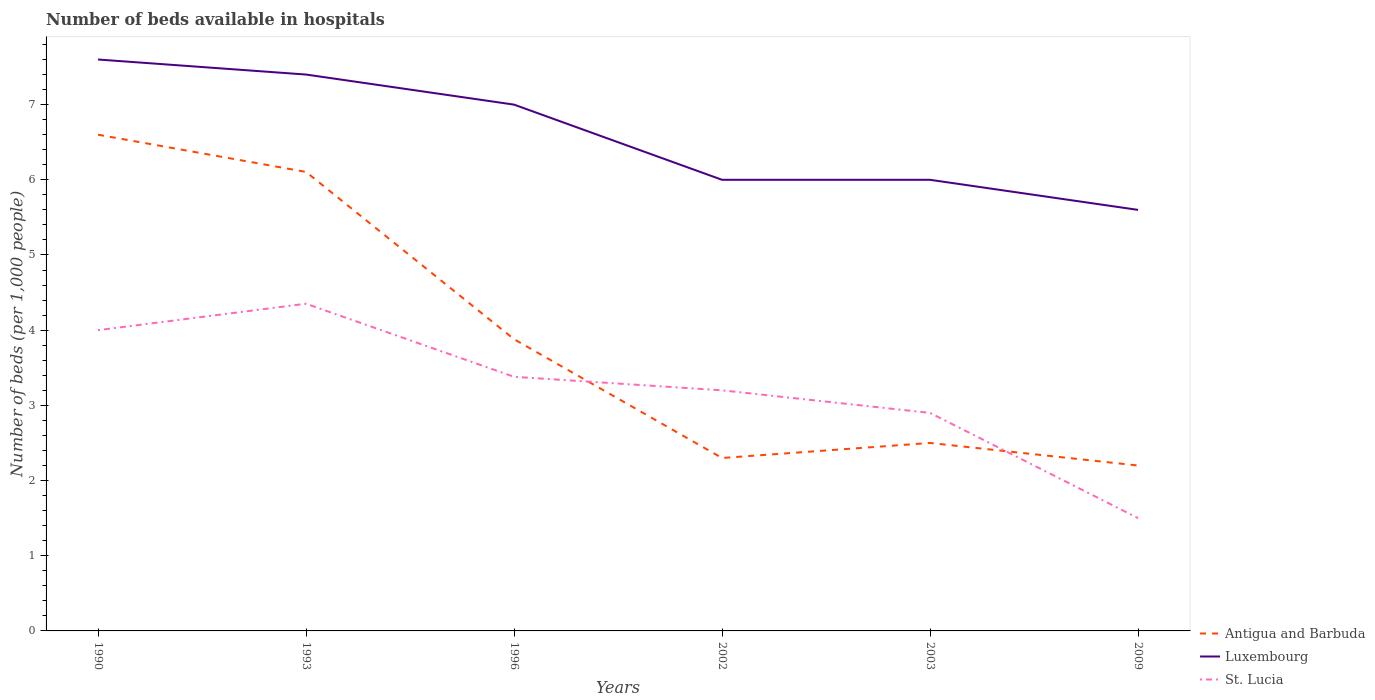What is the total number of beds in the hospiatls of in Antigua and Barbuda in the graph?
Ensure brevity in your answer.  4.1. What is the difference between the highest and the second highest number of beds in the hospiatls of in St. Lucia?
Give a very brief answer. 2.85. How many years are there in the graph?
Your answer should be very brief. 6. Does the graph contain any zero values?
Offer a very short reply. No. Does the graph contain grids?
Ensure brevity in your answer.  No. Where does the legend appear in the graph?
Give a very brief answer. Bottom right. How many legend labels are there?
Offer a very short reply. 3. How are the legend labels stacked?
Make the answer very short. Vertical. What is the title of the graph?
Offer a terse response. Number of beds available in hospitals. What is the label or title of the Y-axis?
Provide a short and direct response. Number of beds (per 1,0 people). What is the Number of beds (per 1,000 people) of Antigua and Barbuda in 1990?
Ensure brevity in your answer.  6.6. What is the Number of beds (per 1,000 people) in Luxembourg in 1990?
Offer a very short reply. 7.6. What is the Number of beds (per 1,000 people) of Antigua and Barbuda in 1993?
Provide a short and direct response. 6.1. What is the Number of beds (per 1,000 people) in Luxembourg in 1993?
Keep it short and to the point. 7.4. What is the Number of beds (per 1,000 people) in St. Lucia in 1993?
Provide a short and direct response. 4.35. What is the Number of beds (per 1,000 people) in Antigua and Barbuda in 1996?
Provide a succinct answer. 3.88. What is the Number of beds (per 1,000 people) in Luxembourg in 1996?
Offer a terse response. 7. What is the Number of beds (per 1,000 people) of St. Lucia in 1996?
Provide a succinct answer. 3.38. What is the Number of beds (per 1,000 people) in Luxembourg in 2002?
Ensure brevity in your answer.  6. What is the Number of beds (per 1,000 people) in St. Lucia in 2002?
Provide a succinct answer. 3.2. What is the Number of beds (per 1,000 people) in Antigua and Barbuda in 2003?
Offer a terse response. 2.5. What is the Number of beds (per 1,000 people) of Luxembourg in 2003?
Ensure brevity in your answer.  6. What is the Number of beds (per 1,000 people) in Antigua and Barbuda in 2009?
Ensure brevity in your answer.  2.2. What is the Number of beds (per 1,000 people) in St. Lucia in 2009?
Ensure brevity in your answer.  1.5. Across all years, what is the maximum Number of beds (per 1,000 people) in Antigua and Barbuda?
Your answer should be very brief. 6.6. Across all years, what is the maximum Number of beds (per 1,000 people) in Luxembourg?
Give a very brief answer. 7.6. Across all years, what is the maximum Number of beds (per 1,000 people) in St. Lucia?
Keep it short and to the point. 4.35. Across all years, what is the minimum Number of beds (per 1,000 people) in Antigua and Barbuda?
Provide a short and direct response. 2.2. What is the total Number of beds (per 1,000 people) of Antigua and Barbuda in the graph?
Give a very brief answer. 23.58. What is the total Number of beds (per 1,000 people) of Luxembourg in the graph?
Your answer should be very brief. 39.6. What is the total Number of beds (per 1,000 people) of St. Lucia in the graph?
Your answer should be very brief. 19.33. What is the difference between the Number of beds (per 1,000 people) of Antigua and Barbuda in 1990 and that in 1993?
Make the answer very short. 0.5. What is the difference between the Number of beds (per 1,000 people) in St. Lucia in 1990 and that in 1993?
Offer a terse response. -0.35. What is the difference between the Number of beds (per 1,000 people) of Antigua and Barbuda in 1990 and that in 1996?
Keep it short and to the point. 2.72. What is the difference between the Number of beds (per 1,000 people) of St. Lucia in 1990 and that in 1996?
Keep it short and to the point. 0.62. What is the difference between the Number of beds (per 1,000 people) of Antigua and Barbuda in 1990 and that in 2002?
Your answer should be very brief. 4.3. What is the difference between the Number of beds (per 1,000 people) of Luxembourg in 1990 and that in 2002?
Offer a terse response. 1.6. What is the difference between the Number of beds (per 1,000 people) in St. Lucia in 1990 and that in 2002?
Provide a short and direct response. 0.8. What is the difference between the Number of beds (per 1,000 people) of St. Lucia in 1990 and that in 2003?
Your answer should be compact. 1.1. What is the difference between the Number of beds (per 1,000 people) in Antigua and Barbuda in 1990 and that in 2009?
Your answer should be compact. 4.4. What is the difference between the Number of beds (per 1,000 people) in Antigua and Barbuda in 1993 and that in 1996?
Offer a terse response. 2.22. What is the difference between the Number of beds (per 1,000 people) of St. Lucia in 1993 and that in 1996?
Keep it short and to the point. 0.97. What is the difference between the Number of beds (per 1,000 people) in Antigua and Barbuda in 1993 and that in 2002?
Provide a short and direct response. 3.8. What is the difference between the Number of beds (per 1,000 people) in Luxembourg in 1993 and that in 2002?
Your answer should be compact. 1.4. What is the difference between the Number of beds (per 1,000 people) in St. Lucia in 1993 and that in 2002?
Offer a terse response. 1.15. What is the difference between the Number of beds (per 1,000 people) in Antigua and Barbuda in 1993 and that in 2003?
Offer a very short reply. 3.6. What is the difference between the Number of beds (per 1,000 people) in St. Lucia in 1993 and that in 2003?
Provide a succinct answer. 1.45. What is the difference between the Number of beds (per 1,000 people) in Antigua and Barbuda in 1993 and that in 2009?
Provide a short and direct response. 3.9. What is the difference between the Number of beds (per 1,000 people) of Luxembourg in 1993 and that in 2009?
Your answer should be compact. 1.8. What is the difference between the Number of beds (per 1,000 people) in St. Lucia in 1993 and that in 2009?
Provide a short and direct response. 2.85. What is the difference between the Number of beds (per 1,000 people) of Antigua and Barbuda in 1996 and that in 2002?
Offer a terse response. 1.58. What is the difference between the Number of beds (per 1,000 people) in St. Lucia in 1996 and that in 2002?
Keep it short and to the point. 0.18. What is the difference between the Number of beds (per 1,000 people) in Antigua and Barbuda in 1996 and that in 2003?
Keep it short and to the point. 1.38. What is the difference between the Number of beds (per 1,000 people) in St. Lucia in 1996 and that in 2003?
Make the answer very short. 0.48. What is the difference between the Number of beds (per 1,000 people) in Antigua and Barbuda in 1996 and that in 2009?
Your answer should be very brief. 1.68. What is the difference between the Number of beds (per 1,000 people) in Luxembourg in 1996 and that in 2009?
Provide a succinct answer. 1.4. What is the difference between the Number of beds (per 1,000 people) in St. Lucia in 1996 and that in 2009?
Ensure brevity in your answer.  1.88. What is the difference between the Number of beds (per 1,000 people) in Antigua and Barbuda in 2002 and that in 2003?
Your answer should be very brief. -0.2. What is the difference between the Number of beds (per 1,000 people) of St. Lucia in 2002 and that in 2003?
Keep it short and to the point. 0.3. What is the difference between the Number of beds (per 1,000 people) of Antigua and Barbuda in 2002 and that in 2009?
Provide a short and direct response. 0.1. What is the difference between the Number of beds (per 1,000 people) in Luxembourg in 2002 and that in 2009?
Make the answer very short. 0.4. What is the difference between the Number of beds (per 1,000 people) of St. Lucia in 2002 and that in 2009?
Make the answer very short. 1.7. What is the difference between the Number of beds (per 1,000 people) of Antigua and Barbuda in 2003 and that in 2009?
Your answer should be compact. 0.3. What is the difference between the Number of beds (per 1,000 people) of Antigua and Barbuda in 1990 and the Number of beds (per 1,000 people) of St. Lucia in 1993?
Your answer should be very brief. 2.25. What is the difference between the Number of beds (per 1,000 people) of Luxembourg in 1990 and the Number of beds (per 1,000 people) of St. Lucia in 1993?
Provide a succinct answer. 3.25. What is the difference between the Number of beds (per 1,000 people) of Antigua and Barbuda in 1990 and the Number of beds (per 1,000 people) of Luxembourg in 1996?
Make the answer very short. -0.4. What is the difference between the Number of beds (per 1,000 people) in Antigua and Barbuda in 1990 and the Number of beds (per 1,000 people) in St. Lucia in 1996?
Your response must be concise. 3.22. What is the difference between the Number of beds (per 1,000 people) of Luxembourg in 1990 and the Number of beds (per 1,000 people) of St. Lucia in 1996?
Ensure brevity in your answer.  4.22. What is the difference between the Number of beds (per 1,000 people) in Antigua and Barbuda in 1990 and the Number of beds (per 1,000 people) in St. Lucia in 2002?
Keep it short and to the point. 3.4. What is the difference between the Number of beds (per 1,000 people) in Luxembourg in 1990 and the Number of beds (per 1,000 people) in St. Lucia in 2002?
Provide a short and direct response. 4.4. What is the difference between the Number of beds (per 1,000 people) of Antigua and Barbuda in 1990 and the Number of beds (per 1,000 people) of Luxembourg in 2003?
Your response must be concise. 0.6. What is the difference between the Number of beds (per 1,000 people) of Antigua and Barbuda in 1990 and the Number of beds (per 1,000 people) of St. Lucia in 2003?
Your answer should be very brief. 3.7. What is the difference between the Number of beds (per 1,000 people) of Luxembourg in 1990 and the Number of beds (per 1,000 people) of St. Lucia in 2009?
Your answer should be very brief. 6.1. What is the difference between the Number of beds (per 1,000 people) in Antigua and Barbuda in 1993 and the Number of beds (per 1,000 people) in Luxembourg in 1996?
Offer a terse response. -0.9. What is the difference between the Number of beds (per 1,000 people) in Antigua and Barbuda in 1993 and the Number of beds (per 1,000 people) in St. Lucia in 1996?
Your answer should be compact. 2.72. What is the difference between the Number of beds (per 1,000 people) in Luxembourg in 1993 and the Number of beds (per 1,000 people) in St. Lucia in 1996?
Your response must be concise. 4.02. What is the difference between the Number of beds (per 1,000 people) of Antigua and Barbuda in 1993 and the Number of beds (per 1,000 people) of Luxembourg in 2002?
Offer a terse response. 0.1. What is the difference between the Number of beds (per 1,000 people) in Antigua and Barbuda in 1993 and the Number of beds (per 1,000 people) in St. Lucia in 2002?
Provide a succinct answer. 2.9. What is the difference between the Number of beds (per 1,000 people) of Luxembourg in 1993 and the Number of beds (per 1,000 people) of St. Lucia in 2002?
Offer a very short reply. 4.2. What is the difference between the Number of beds (per 1,000 people) of Antigua and Barbuda in 1993 and the Number of beds (per 1,000 people) of Luxembourg in 2003?
Your answer should be very brief. 0.1. What is the difference between the Number of beds (per 1,000 people) in Antigua and Barbuda in 1993 and the Number of beds (per 1,000 people) in St. Lucia in 2003?
Make the answer very short. 3.2. What is the difference between the Number of beds (per 1,000 people) of Luxembourg in 1993 and the Number of beds (per 1,000 people) of St. Lucia in 2003?
Provide a succinct answer. 4.5. What is the difference between the Number of beds (per 1,000 people) of Antigua and Barbuda in 1993 and the Number of beds (per 1,000 people) of Luxembourg in 2009?
Keep it short and to the point. 0.5. What is the difference between the Number of beds (per 1,000 people) in Antigua and Barbuda in 1993 and the Number of beds (per 1,000 people) in St. Lucia in 2009?
Make the answer very short. 4.6. What is the difference between the Number of beds (per 1,000 people) of Antigua and Barbuda in 1996 and the Number of beds (per 1,000 people) of Luxembourg in 2002?
Keep it short and to the point. -2.12. What is the difference between the Number of beds (per 1,000 people) in Antigua and Barbuda in 1996 and the Number of beds (per 1,000 people) in St. Lucia in 2002?
Ensure brevity in your answer.  0.68. What is the difference between the Number of beds (per 1,000 people) in Luxembourg in 1996 and the Number of beds (per 1,000 people) in St. Lucia in 2002?
Give a very brief answer. 3.8. What is the difference between the Number of beds (per 1,000 people) in Antigua and Barbuda in 1996 and the Number of beds (per 1,000 people) in Luxembourg in 2003?
Your answer should be very brief. -2.12. What is the difference between the Number of beds (per 1,000 people) in Antigua and Barbuda in 1996 and the Number of beds (per 1,000 people) in Luxembourg in 2009?
Offer a very short reply. -1.72. What is the difference between the Number of beds (per 1,000 people) in Antigua and Barbuda in 1996 and the Number of beds (per 1,000 people) in St. Lucia in 2009?
Provide a short and direct response. 2.38. What is the difference between the Number of beds (per 1,000 people) in Antigua and Barbuda in 2002 and the Number of beds (per 1,000 people) in St. Lucia in 2003?
Offer a very short reply. -0.6. What is the difference between the Number of beds (per 1,000 people) in Antigua and Barbuda in 2002 and the Number of beds (per 1,000 people) in Luxembourg in 2009?
Ensure brevity in your answer.  -3.3. What is the difference between the Number of beds (per 1,000 people) of Antigua and Barbuda in 2003 and the Number of beds (per 1,000 people) of Luxembourg in 2009?
Your answer should be very brief. -3.1. What is the difference between the Number of beds (per 1,000 people) in Luxembourg in 2003 and the Number of beds (per 1,000 people) in St. Lucia in 2009?
Give a very brief answer. 4.5. What is the average Number of beds (per 1,000 people) of Antigua and Barbuda per year?
Your response must be concise. 3.93. What is the average Number of beds (per 1,000 people) of St. Lucia per year?
Offer a terse response. 3.22. In the year 1990, what is the difference between the Number of beds (per 1,000 people) in Antigua and Barbuda and Number of beds (per 1,000 people) in St. Lucia?
Keep it short and to the point. 2.6. In the year 1993, what is the difference between the Number of beds (per 1,000 people) of Antigua and Barbuda and Number of beds (per 1,000 people) of Luxembourg?
Your answer should be very brief. -1.3. In the year 1993, what is the difference between the Number of beds (per 1,000 people) of Antigua and Barbuda and Number of beds (per 1,000 people) of St. Lucia?
Your answer should be compact. 1.75. In the year 1993, what is the difference between the Number of beds (per 1,000 people) of Luxembourg and Number of beds (per 1,000 people) of St. Lucia?
Provide a succinct answer. 3.05. In the year 1996, what is the difference between the Number of beds (per 1,000 people) of Antigua and Barbuda and Number of beds (per 1,000 people) of Luxembourg?
Your answer should be very brief. -3.12. In the year 1996, what is the difference between the Number of beds (per 1,000 people) in Luxembourg and Number of beds (per 1,000 people) in St. Lucia?
Your answer should be very brief. 3.62. In the year 2002, what is the difference between the Number of beds (per 1,000 people) in Antigua and Barbuda and Number of beds (per 1,000 people) in Luxembourg?
Your response must be concise. -3.7. In the year 2003, what is the difference between the Number of beds (per 1,000 people) of Antigua and Barbuda and Number of beds (per 1,000 people) of Luxembourg?
Provide a succinct answer. -3.5. In the year 2009, what is the difference between the Number of beds (per 1,000 people) of Luxembourg and Number of beds (per 1,000 people) of St. Lucia?
Your answer should be very brief. 4.1. What is the ratio of the Number of beds (per 1,000 people) in Antigua and Barbuda in 1990 to that in 1993?
Your response must be concise. 1.08. What is the ratio of the Number of beds (per 1,000 people) of St. Lucia in 1990 to that in 1993?
Keep it short and to the point. 0.92. What is the ratio of the Number of beds (per 1,000 people) of Antigua and Barbuda in 1990 to that in 1996?
Provide a short and direct response. 1.7. What is the ratio of the Number of beds (per 1,000 people) in Luxembourg in 1990 to that in 1996?
Your answer should be very brief. 1.09. What is the ratio of the Number of beds (per 1,000 people) in St. Lucia in 1990 to that in 1996?
Keep it short and to the point. 1.18. What is the ratio of the Number of beds (per 1,000 people) of Antigua and Barbuda in 1990 to that in 2002?
Your answer should be very brief. 2.87. What is the ratio of the Number of beds (per 1,000 people) in Luxembourg in 1990 to that in 2002?
Give a very brief answer. 1.27. What is the ratio of the Number of beds (per 1,000 people) in St. Lucia in 1990 to that in 2002?
Make the answer very short. 1.25. What is the ratio of the Number of beds (per 1,000 people) of Antigua and Barbuda in 1990 to that in 2003?
Provide a short and direct response. 2.64. What is the ratio of the Number of beds (per 1,000 people) in Luxembourg in 1990 to that in 2003?
Offer a very short reply. 1.27. What is the ratio of the Number of beds (per 1,000 people) in St. Lucia in 1990 to that in 2003?
Offer a terse response. 1.38. What is the ratio of the Number of beds (per 1,000 people) in Luxembourg in 1990 to that in 2009?
Offer a terse response. 1.36. What is the ratio of the Number of beds (per 1,000 people) in St. Lucia in 1990 to that in 2009?
Provide a succinct answer. 2.67. What is the ratio of the Number of beds (per 1,000 people) in Antigua and Barbuda in 1993 to that in 1996?
Your answer should be very brief. 1.57. What is the ratio of the Number of beds (per 1,000 people) of Luxembourg in 1993 to that in 1996?
Give a very brief answer. 1.06. What is the ratio of the Number of beds (per 1,000 people) in St. Lucia in 1993 to that in 1996?
Give a very brief answer. 1.29. What is the ratio of the Number of beds (per 1,000 people) in Antigua and Barbuda in 1993 to that in 2002?
Provide a succinct answer. 2.65. What is the ratio of the Number of beds (per 1,000 people) of Luxembourg in 1993 to that in 2002?
Your answer should be very brief. 1.23. What is the ratio of the Number of beds (per 1,000 people) of St. Lucia in 1993 to that in 2002?
Offer a very short reply. 1.36. What is the ratio of the Number of beds (per 1,000 people) in Antigua and Barbuda in 1993 to that in 2003?
Make the answer very short. 2.44. What is the ratio of the Number of beds (per 1,000 people) of Luxembourg in 1993 to that in 2003?
Offer a terse response. 1.23. What is the ratio of the Number of beds (per 1,000 people) in St. Lucia in 1993 to that in 2003?
Ensure brevity in your answer.  1.5. What is the ratio of the Number of beds (per 1,000 people) of Antigua and Barbuda in 1993 to that in 2009?
Provide a short and direct response. 2.77. What is the ratio of the Number of beds (per 1,000 people) of Luxembourg in 1993 to that in 2009?
Your response must be concise. 1.32. What is the ratio of the Number of beds (per 1,000 people) of St. Lucia in 1993 to that in 2009?
Provide a succinct answer. 2.9. What is the ratio of the Number of beds (per 1,000 people) in Antigua and Barbuda in 1996 to that in 2002?
Your answer should be compact. 1.69. What is the ratio of the Number of beds (per 1,000 people) of Luxembourg in 1996 to that in 2002?
Your answer should be very brief. 1.17. What is the ratio of the Number of beds (per 1,000 people) of St. Lucia in 1996 to that in 2002?
Your response must be concise. 1.06. What is the ratio of the Number of beds (per 1,000 people) of Antigua and Barbuda in 1996 to that in 2003?
Keep it short and to the point. 1.55. What is the ratio of the Number of beds (per 1,000 people) in Luxembourg in 1996 to that in 2003?
Ensure brevity in your answer.  1.17. What is the ratio of the Number of beds (per 1,000 people) in St. Lucia in 1996 to that in 2003?
Provide a succinct answer. 1.17. What is the ratio of the Number of beds (per 1,000 people) of Antigua and Barbuda in 1996 to that in 2009?
Your answer should be compact. 1.76. What is the ratio of the Number of beds (per 1,000 people) of St. Lucia in 1996 to that in 2009?
Provide a short and direct response. 2.25. What is the ratio of the Number of beds (per 1,000 people) in St. Lucia in 2002 to that in 2003?
Provide a succinct answer. 1.1. What is the ratio of the Number of beds (per 1,000 people) of Antigua and Barbuda in 2002 to that in 2009?
Offer a terse response. 1.05. What is the ratio of the Number of beds (per 1,000 people) in Luxembourg in 2002 to that in 2009?
Your answer should be very brief. 1.07. What is the ratio of the Number of beds (per 1,000 people) of St. Lucia in 2002 to that in 2009?
Offer a terse response. 2.13. What is the ratio of the Number of beds (per 1,000 people) of Antigua and Barbuda in 2003 to that in 2009?
Ensure brevity in your answer.  1.14. What is the ratio of the Number of beds (per 1,000 people) of Luxembourg in 2003 to that in 2009?
Give a very brief answer. 1.07. What is the ratio of the Number of beds (per 1,000 people) of St. Lucia in 2003 to that in 2009?
Your answer should be very brief. 1.93. What is the difference between the highest and the second highest Number of beds (per 1,000 people) of Antigua and Barbuda?
Your answer should be very brief. 0.5. What is the difference between the highest and the second highest Number of beds (per 1,000 people) in Luxembourg?
Your answer should be compact. 0.2. What is the difference between the highest and the second highest Number of beds (per 1,000 people) in St. Lucia?
Provide a succinct answer. 0.35. What is the difference between the highest and the lowest Number of beds (per 1,000 people) of St. Lucia?
Make the answer very short. 2.85. 